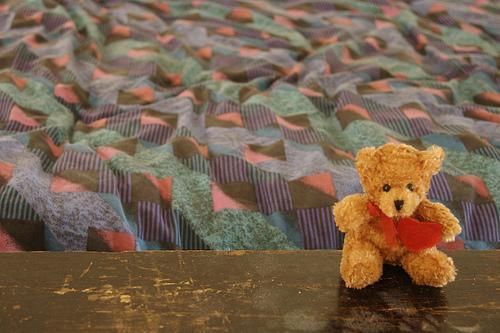How many people are in the picture?
Give a very brief answer. 0. How many laptops are on?
Give a very brief answer. 0. 